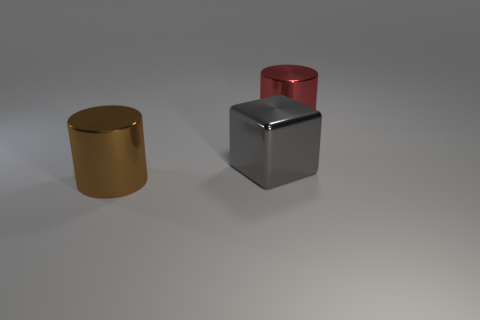Add 1 small cyan shiny objects. How many objects exist? 4 Subtract all cylinders. How many objects are left? 1 Add 2 brown metal cylinders. How many brown metal cylinders are left? 3 Add 3 big metal blocks. How many big metal blocks exist? 4 Subtract 0 yellow cubes. How many objects are left? 3 Subtract all tiny cyan rubber spheres. Subtract all metal objects. How many objects are left? 0 